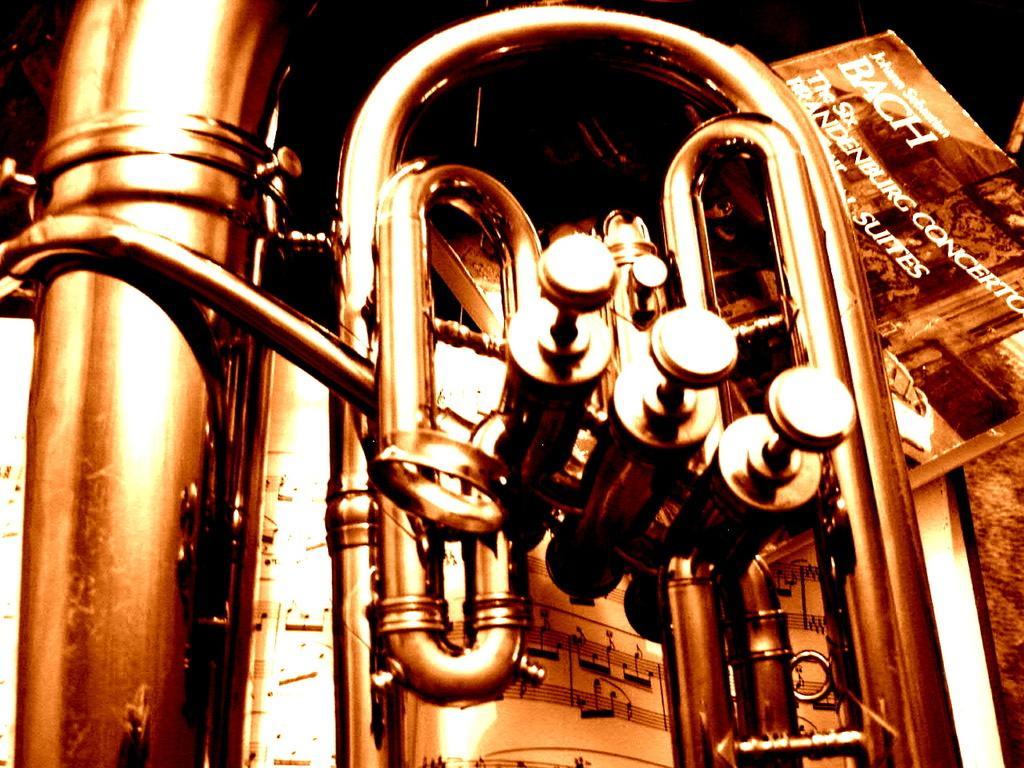Can you describe this image briefly? In this picture we can observe a trumpet which is in gold color. We can observe a book on the right side. The background is dark. 